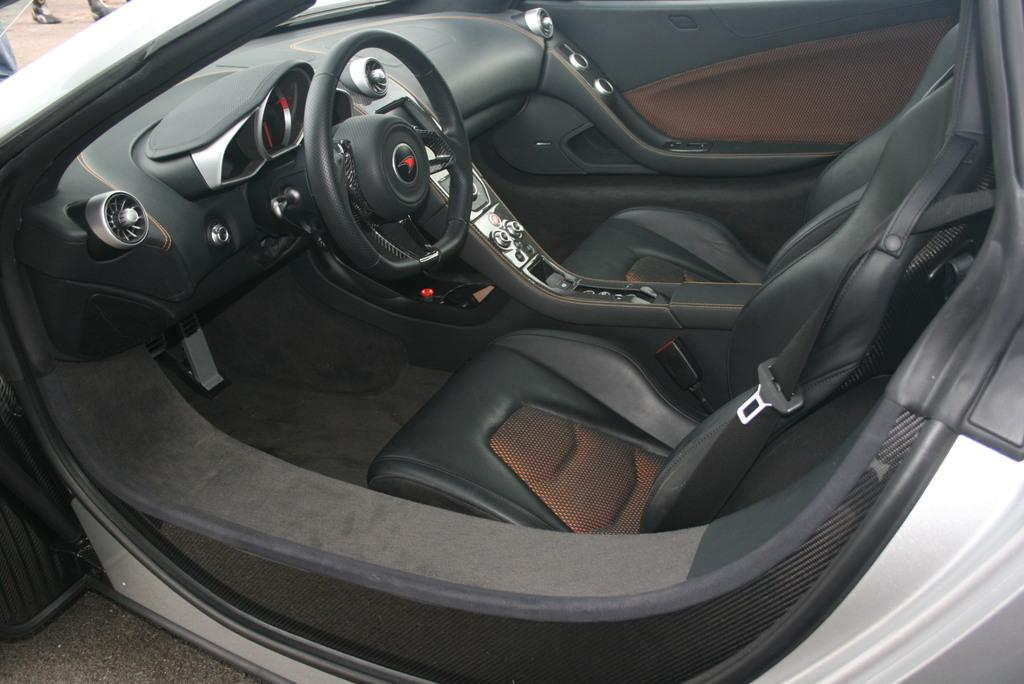Where was the image taken? The image is taken outdoors. What can be seen at the bottom of the image? There is a road at the bottom of the image. What is in the middle of the image? There is a car in the middle of the image. Can you describe the person at the top left of the image? There is a person at the top left of the image. What type of servant can be seen in the image? There is no servant present in the image. 